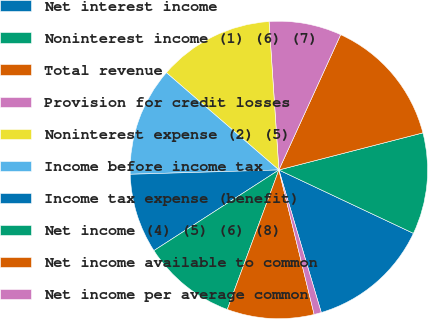Convert chart. <chart><loc_0><loc_0><loc_500><loc_500><pie_chart><fcel>Net interest income<fcel>Noninterest income (1) (6) (7)<fcel>Total revenue<fcel>Provision for credit losses<fcel>Noninterest expense (2) (5)<fcel>Income before income tax<fcel>Income tax expense (benefit)<fcel>Net income (4) (5) (6) (8)<fcel>Net income available to common<fcel>Net income per average common<nl><fcel>13.39%<fcel>11.02%<fcel>14.17%<fcel>7.87%<fcel>12.6%<fcel>11.81%<fcel>8.66%<fcel>10.24%<fcel>9.45%<fcel>0.79%<nl></chart> 